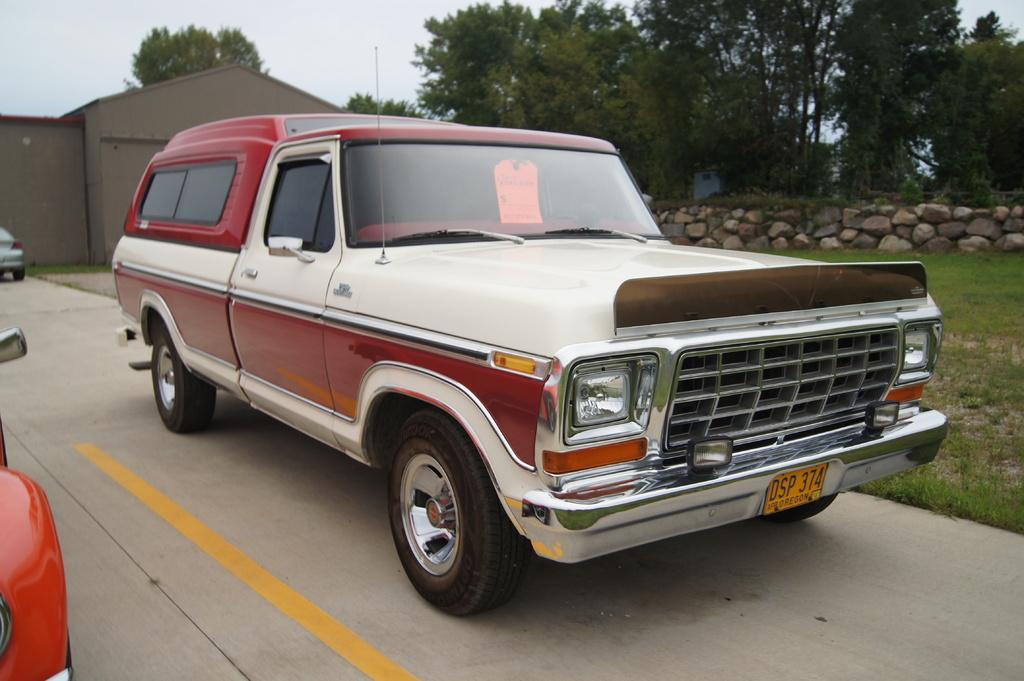How would you summarize this image in a sentence or two? In this image, I can see a car, which is parked. This is the road. These are the trees and the rocks. This is the grass. This looks like a house. At the top of the image, I can see the sky. On the left corner of the image, I can see the vehicles. 